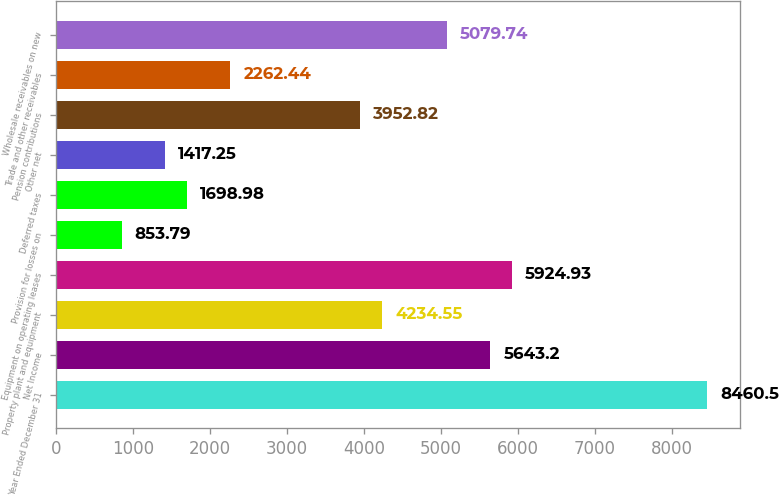Convert chart to OTSL. <chart><loc_0><loc_0><loc_500><loc_500><bar_chart><fcel>Year Ended December 31<fcel>Net Income<fcel>Property plant and equipment<fcel>Equipment on operating leases<fcel>Provision for losses on<fcel>Deferred taxes<fcel>Other net<fcel>Pension contributions<fcel>Trade and other receivables<fcel>Wholesale receivables on new<nl><fcel>8460.5<fcel>5643.2<fcel>4234.55<fcel>5924.93<fcel>853.79<fcel>1698.98<fcel>1417.25<fcel>3952.82<fcel>2262.44<fcel>5079.74<nl></chart> 